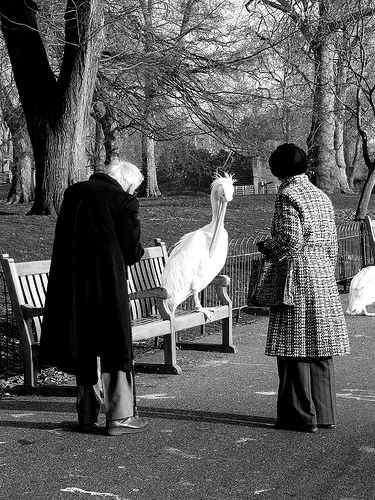Please provide the bounding box coordinate of the region this sentence describes: the shoe of a man. [0.34, 0.83, 0.43, 0.87] 